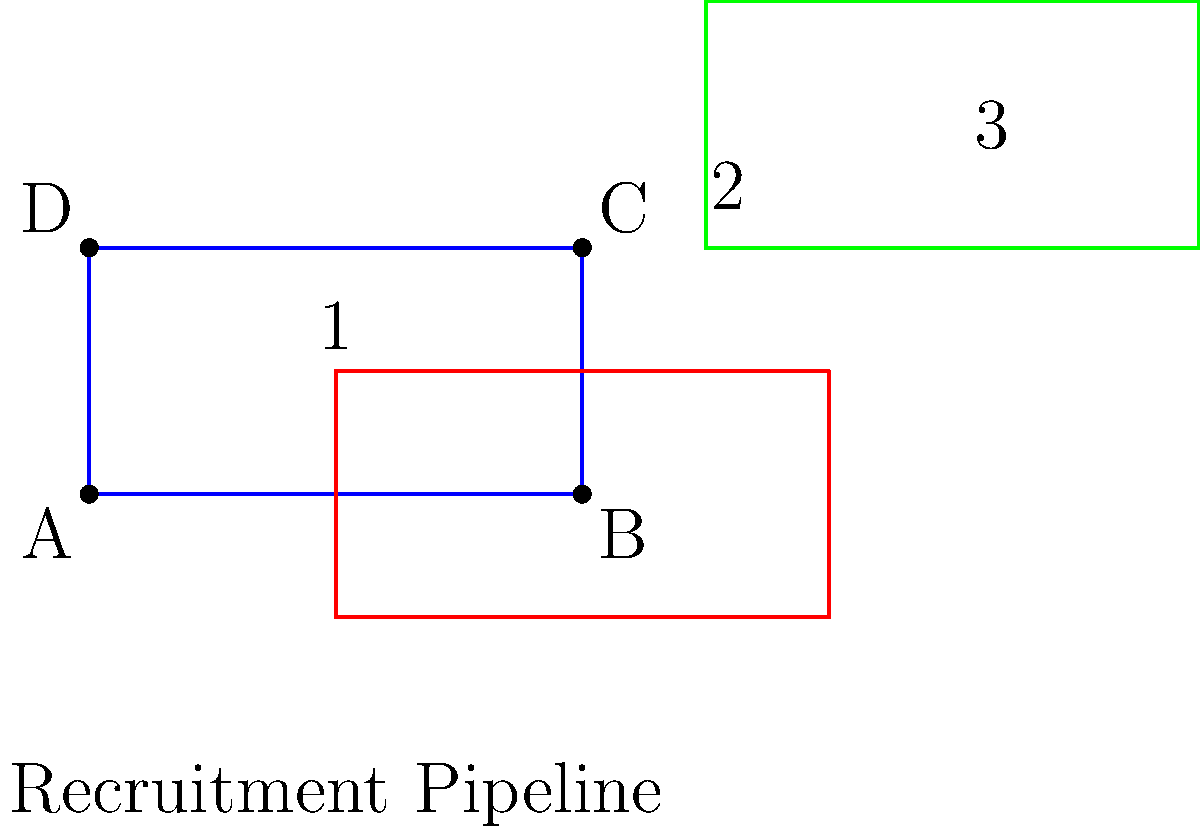A rectangular diagram representing a recruitment pipeline undergoes a series of transformations. The original blue rectangle (1) is first transformed into the red rectangle (2), and then into the green rectangle (3). Identify the sequence of transformations applied to move from the blue rectangle to the green rectangle. To identify the sequence of transformations, we need to analyze the changes from the blue rectangle (1) to the red rectangle (2), and then from the red rectangle (2) to the green rectangle (3).

Step 1: Blue rectangle (1) to red rectangle (2)
- The shape is translated downward and to the right.
- The size remains the same.
Transformation: Translation

Step 2: Red rectangle (2) to green rectangle (3)
- The shape is moved upward and to the right.
- The size remains the same.
Transformation: Translation

Step 3: Overall transformation
Since both steps involve translations, the overall transformation from the blue rectangle (1) to the green rectangle (3) is a single translation.

To determine the exact translation:
- Horizontal shift: From left edge of blue to left edge of green = 5 units right
- Vertical shift: From bottom edge of blue to bottom edge of green = 2 units up

Therefore, the single transformation is a translation of 5 units right and 2 units up, which can be represented as a vector $\vec{v} = (5, 2)$.
Answer: Translation by vector $\vec{v} = (5, 2)$ 